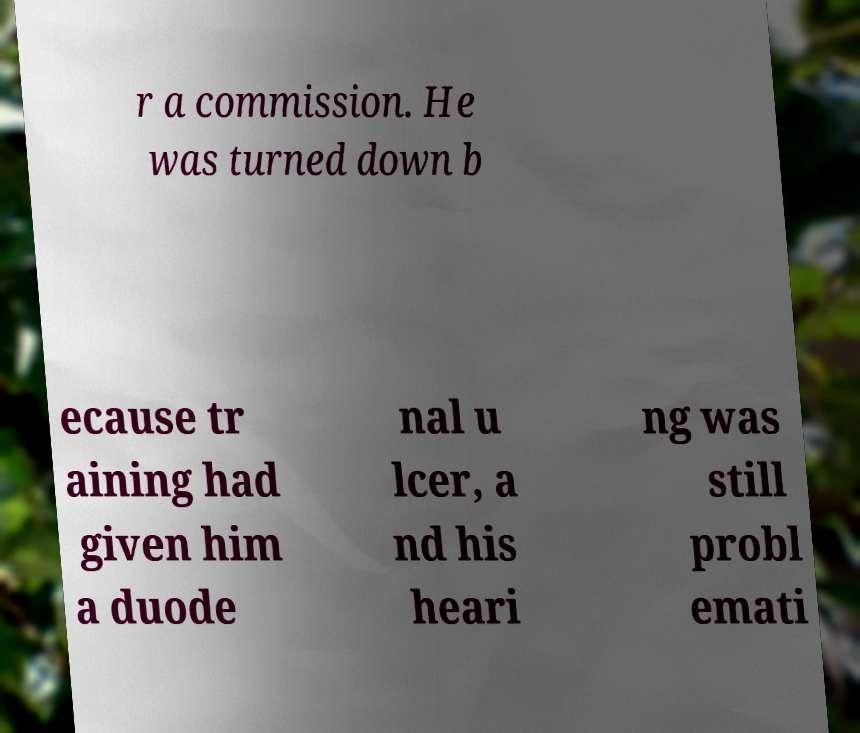Can you accurately transcribe the text from the provided image for me? r a commission. He was turned down b ecause tr aining had given him a duode nal u lcer, a nd his heari ng was still probl emati 